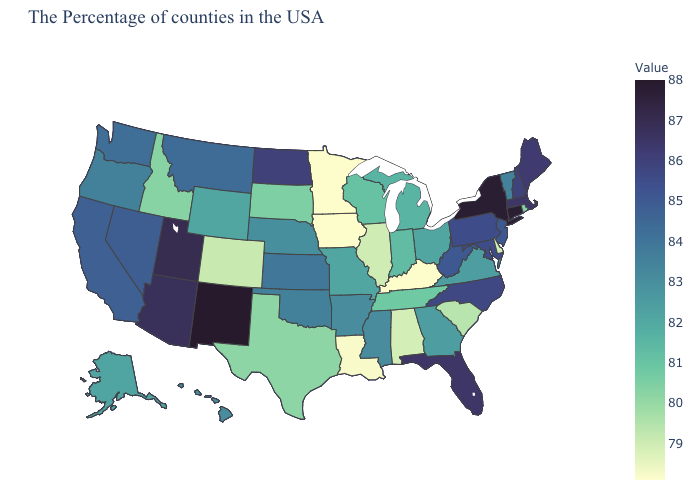Does California have a lower value than Florida?
Short answer required. Yes. Which states hav the highest value in the MidWest?
Short answer required. North Dakota. Does South Dakota have a higher value than Nebraska?
Quick response, please. No. Among the states that border Vermont , does Massachusetts have the lowest value?
Concise answer only. No. 